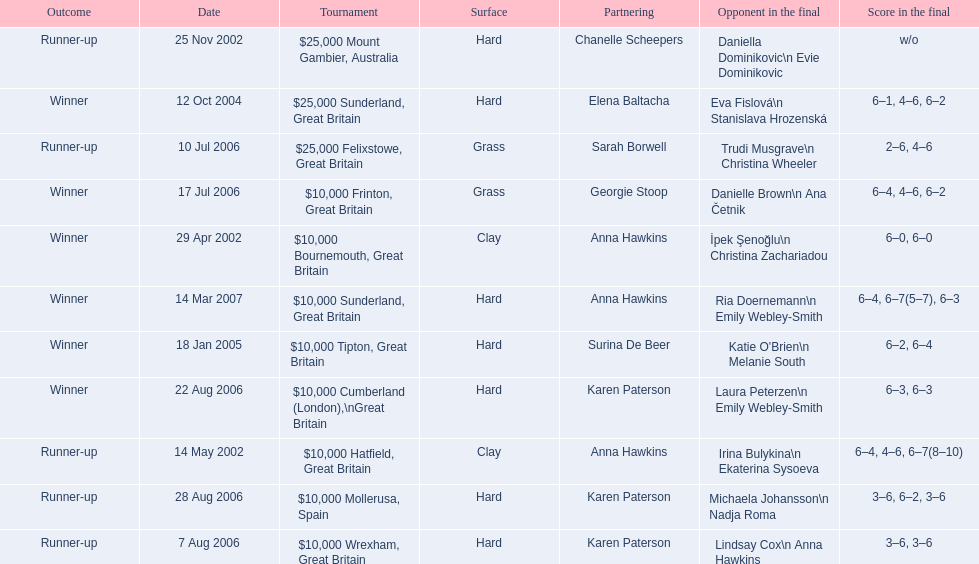What is the partnering name above chanelle scheepers? Anna Hawkins. 